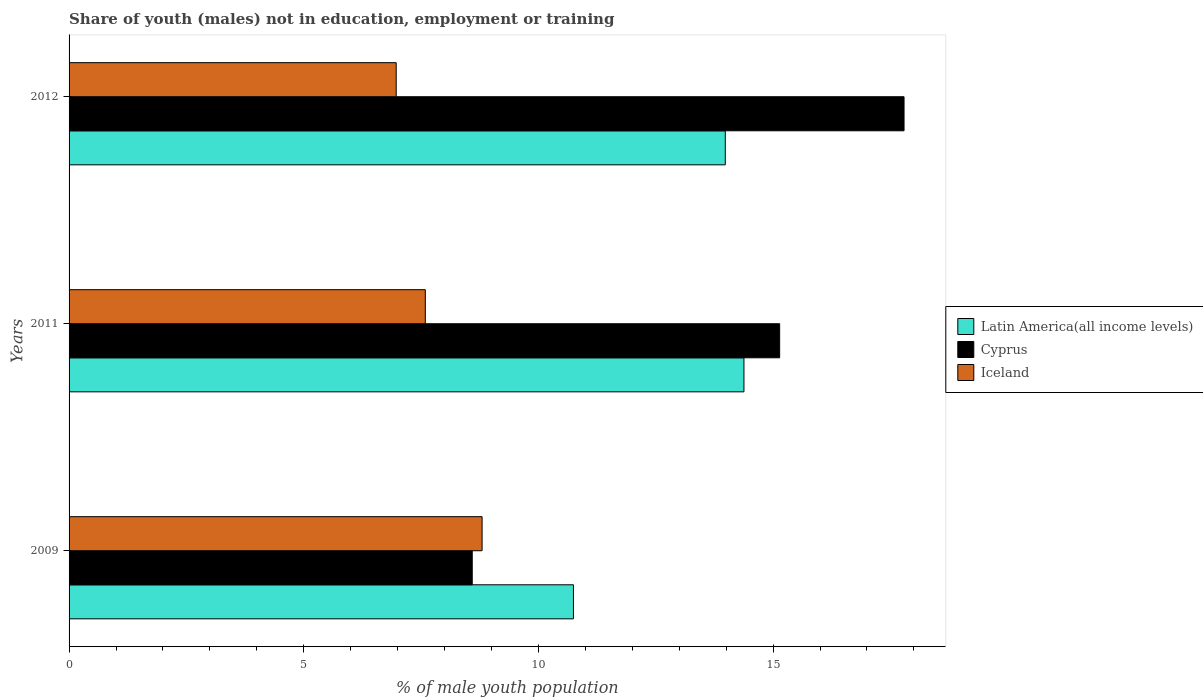How many different coloured bars are there?
Provide a short and direct response. 3. How many groups of bars are there?
Your response must be concise. 3. Are the number of bars per tick equal to the number of legend labels?
Your answer should be very brief. Yes. How many bars are there on the 3rd tick from the top?
Your answer should be compact. 3. How many bars are there on the 1st tick from the bottom?
Provide a short and direct response. 3. In how many cases, is the number of bars for a given year not equal to the number of legend labels?
Offer a terse response. 0. What is the percentage of unemployed males population in in Iceland in 2009?
Your response must be concise. 8.8. Across all years, what is the maximum percentage of unemployed males population in in Iceland?
Offer a very short reply. 8.8. Across all years, what is the minimum percentage of unemployed males population in in Iceland?
Your answer should be compact. 6.97. In which year was the percentage of unemployed males population in in Cyprus maximum?
Provide a short and direct response. 2012. In which year was the percentage of unemployed males population in in Iceland minimum?
Ensure brevity in your answer.  2012. What is the total percentage of unemployed males population in in Latin America(all income levels) in the graph?
Make the answer very short. 39.11. What is the difference between the percentage of unemployed males population in in Latin America(all income levels) in 2009 and that in 2011?
Your answer should be very brief. -3.63. What is the difference between the percentage of unemployed males population in in Iceland in 2009 and the percentage of unemployed males population in in Latin America(all income levels) in 2011?
Give a very brief answer. -5.58. What is the average percentage of unemployed males population in in Latin America(all income levels) per year?
Keep it short and to the point. 13.04. In the year 2011, what is the difference between the percentage of unemployed males population in in Iceland and percentage of unemployed males population in in Cyprus?
Offer a terse response. -7.55. In how many years, is the percentage of unemployed males population in in Cyprus greater than 12 %?
Your response must be concise. 2. What is the ratio of the percentage of unemployed males population in in Cyprus in 2011 to that in 2012?
Provide a short and direct response. 0.85. What is the difference between the highest and the second highest percentage of unemployed males population in in Latin America(all income levels)?
Your response must be concise. 0.4. What is the difference between the highest and the lowest percentage of unemployed males population in in Iceland?
Your answer should be compact. 1.83. What does the 1st bar from the bottom in 2009 represents?
Give a very brief answer. Latin America(all income levels). Is it the case that in every year, the sum of the percentage of unemployed males population in in Iceland and percentage of unemployed males population in in Latin America(all income levels) is greater than the percentage of unemployed males population in in Cyprus?
Make the answer very short. Yes. Are all the bars in the graph horizontal?
Your response must be concise. Yes. What is the difference between two consecutive major ticks on the X-axis?
Keep it short and to the point. 5. Are the values on the major ticks of X-axis written in scientific E-notation?
Give a very brief answer. No. Does the graph contain any zero values?
Ensure brevity in your answer.  No. How many legend labels are there?
Provide a succinct answer. 3. What is the title of the graph?
Give a very brief answer. Share of youth (males) not in education, employment or training. Does "St. Kitts and Nevis" appear as one of the legend labels in the graph?
Provide a short and direct response. No. What is the label or title of the X-axis?
Provide a short and direct response. % of male youth population. What is the % of male youth population in Latin America(all income levels) in 2009?
Provide a short and direct response. 10.75. What is the % of male youth population in Cyprus in 2009?
Give a very brief answer. 8.59. What is the % of male youth population of Iceland in 2009?
Provide a succinct answer. 8.8. What is the % of male youth population of Latin America(all income levels) in 2011?
Provide a short and direct response. 14.38. What is the % of male youth population of Cyprus in 2011?
Make the answer very short. 15.14. What is the % of male youth population in Iceland in 2011?
Give a very brief answer. 7.59. What is the % of male youth population in Latin America(all income levels) in 2012?
Give a very brief answer. 13.98. What is the % of male youth population in Cyprus in 2012?
Offer a terse response. 17.79. What is the % of male youth population of Iceland in 2012?
Your answer should be compact. 6.97. Across all years, what is the maximum % of male youth population in Latin America(all income levels)?
Your answer should be very brief. 14.38. Across all years, what is the maximum % of male youth population of Cyprus?
Provide a short and direct response. 17.79. Across all years, what is the maximum % of male youth population in Iceland?
Your answer should be compact. 8.8. Across all years, what is the minimum % of male youth population of Latin America(all income levels)?
Keep it short and to the point. 10.75. Across all years, what is the minimum % of male youth population of Cyprus?
Give a very brief answer. 8.59. Across all years, what is the minimum % of male youth population in Iceland?
Provide a short and direct response. 6.97. What is the total % of male youth population of Latin America(all income levels) in the graph?
Offer a very short reply. 39.11. What is the total % of male youth population in Cyprus in the graph?
Offer a terse response. 41.52. What is the total % of male youth population in Iceland in the graph?
Your response must be concise. 23.36. What is the difference between the % of male youth population in Latin America(all income levels) in 2009 and that in 2011?
Give a very brief answer. -3.63. What is the difference between the % of male youth population of Cyprus in 2009 and that in 2011?
Give a very brief answer. -6.55. What is the difference between the % of male youth population of Iceland in 2009 and that in 2011?
Provide a succinct answer. 1.21. What is the difference between the % of male youth population of Latin America(all income levels) in 2009 and that in 2012?
Your answer should be very brief. -3.24. What is the difference between the % of male youth population of Cyprus in 2009 and that in 2012?
Your answer should be very brief. -9.2. What is the difference between the % of male youth population of Iceland in 2009 and that in 2012?
Make the answer very short. 1.83. What is the difference between the % of male youth population of Latin America(all income levels) in 2011 and that in 2012?
Give a very brief answer. 0.4. What is the difference between the % of male youth population in Cyprus in 2011 and that in 2012?
Your answer should be very brief. -2.65. What is the difference between the % of male youth population in Iceland in 2011 and that in 2012?
Provide a succinct answer. 0.62. What is the difference between the % of male youth population of Latin America(all income levels) in 2009 and the % of male youth population of Cyprus in 2011?
Keep it short and to the point. -4.39. What is the difference between the % of male youth population in Latin America(all income levels) in 2009 and the % of male youth population in Iceland in 2011?
Provide a succinct answer. 3.16. What is the difference between the % of male youth population in Cyprus in 2009 and the % of male youth population in Iceland in 2011?
Offer a terse response. 1. What is the difference between the % of male youth population of Latin America(all income levels) in 2009 and the % of male youth population of Cyprus in 2012?
Offer a very short reply. -7.04. What is the difference between the % of male youth population in Latin America(all income levels) in 2009 and the % of male youth population in Iceland in 2012?
Make the answer very short. 3.78. What is the difference between the % of male youth population of Cyprus in 2009 and the % of male youth population of Iceland in 2012?
Ensure brevity in your answer.  1.62. What is the difference between the % of male youth population in Latin America(all income levels) in 2011 and the % of male youth population in Cyprus in 2012?
Give a very brief answer. -3.41. What is the difference between the % of male youth population of Latin America(all income levels) in 2011 and the % of male youth population of Iceland in 2012?
Offer a terse response. 7.41. What is the difference between the % of male youth population of Cyprus in 2011 and the % of male youth population of Iceland in 2012?
Your answer should be compact. 8.17. What is the average % of male youth population in Latin America(all income levels) per year?
Provide a succinct answer. 13.04. What is the average % of male youth population in Cyprus per year?
Your answer should be very brief. 13.84. What is the average % of male youth population of Iceland per year?
Offer a terse response. 7.79. In the year 2009, what is the difference between the % of male youth population in Latin America(all income levels) and % of male youth population in Cyprus?
Provide a short and direct response. 2.16. In the year 2009, what is the difference between the % of male youth population of Latin America(all income levels) and % of male youth population of Iceland?
Your response must be concise. 1.95. In the year 2009, what is the difference between the % of male youth population in Cyprus and % of male youth population in Iceland?
Offer a terse response. -0.21. In the year 2011, what is the difference between the % of male youth population of Latin America(all income levels) and % of male youth population of Cyprus?
Your answer should be compact. -0.76. In the year 2011, what is the difference between the % of male youth population of Latin America(all income levels) and % of male youth population of Iceland?
Give a very brief answer. 6.79. In the year 2011, what is the difference between the % of male youth population of Cyprus and % of male youth population of Iceland?
Ensure brevity in your answer.  7.55. In the year 2012, what is the difference between the % of male youth population in Latin America(all income levels) and % of male youth population in Cyprus?
Provide a short and direct response. -3.81. In the year 2012, what is the difference between the % of male youth population in Latin America(all income levels) and % of male youth population in Iceland?
Provide a short and direct response. 7.01. In the year 2012, what is the difference between the % of male youth population in Cyprus and % of male youth population in Iceland?
Your answer should be very brief. 10.82. What is the ratio of the % of male youth population of Latin America(all income levels) in 2009 to that in 2011?
Your answer should be very brief. 0.75. What is the ratio of the % of male youth population in Cyprus in 2009 to that in 2011?
Provide a short and direct response. 0.57. What is the ratio of the % of male youth population of Iceland in 2009 to that in 2011?
Offer a terse response. 1.16. What is the ratio of the % of male youth population in Latin America(all income levels) in 2009 to that in 2012?
Provide a short and direct response. 0.77. What is the ratio of the % of male youth population of Cyprus in 2009 to that in 2012?
Give a very brief answer. 0.48. What is the ratio of the % of male youth population of Iceland in 2009 to that in 2012?
Offer a terse response. 1.26. What is the ratio of the % of male youth population of Latin America(all income levels) in 2011 to that in 2012?
Give a very brief answer. 1.03. What is the ratio of the % of male youth population of Cyprus in 2011 to that in 2012?
Your answer should be very brief. 0.85. What is the ratio of the % of male youth population of Iceland in 2011 to that in 2012?
Keep it short and to the point. 1.09. What is the difference between the highest and the second highest % of male youth population in Latin America(all income levels)?
Offer a terse response. 0.4. What is the difference between the highest and the second highest % of male youth population of Cyprus?
Give a very brief answer. 2.65. What is the difference between the highest and the second highest % of male youth population in Iceland?
Provide a succinct answer. 1.21. What is the difference between the highest and the lowest % of male youth population of Latin America(all income levels)?
Offer a terse response. 3.63. What is the difference between the highest and the lowest % of male youth population of Iceland?
Ensure brevity in your answer.  1.83. 